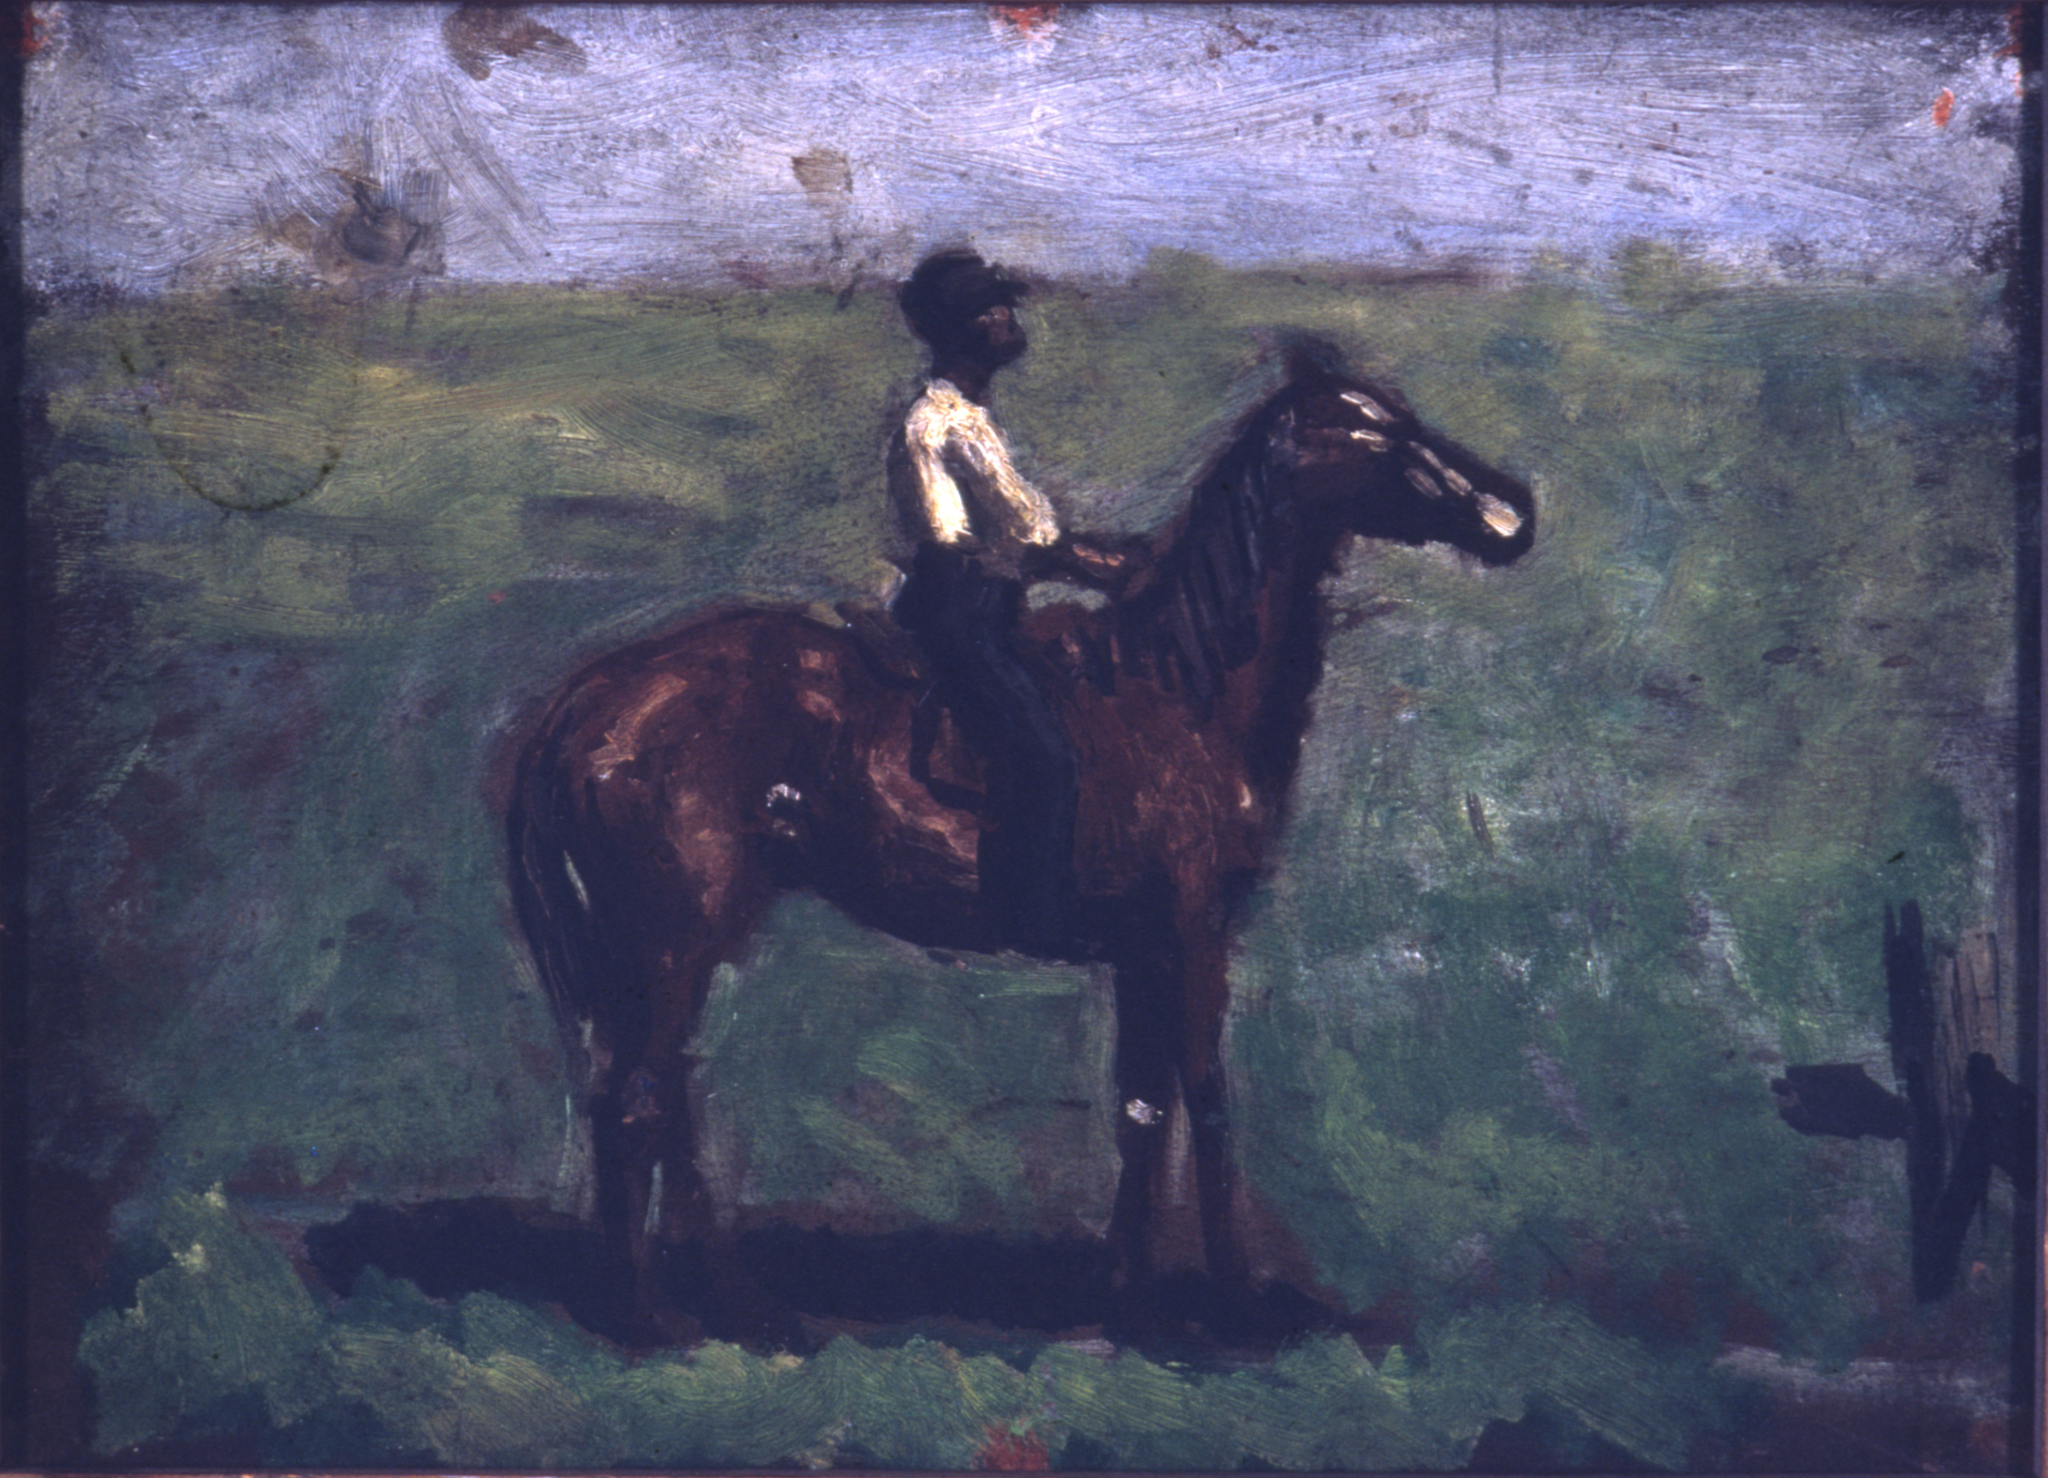What is the theme of this painting, and how does it reflect the period it comes from? The theme of this painting revolves around the harmony between man and nature. In this artwork, the rider's solitary journey through the serene landscape speaks to a period where exploration and the appreciation of natural surroundings were highly valued. Reflecting late 19th to early 20th century ideals, the painting captures a moment of tranquil coexistence, a common sentiment during the era of impressionism where capturing the essence of a scene took precedence over the intricacies. Can you provide a short poem inspired by this painting? In verdant fields where shadows play, 
A rider strides in twilight's ray. 
With gentle brush in hand's swift might, 
The landscape whispers of the night. 